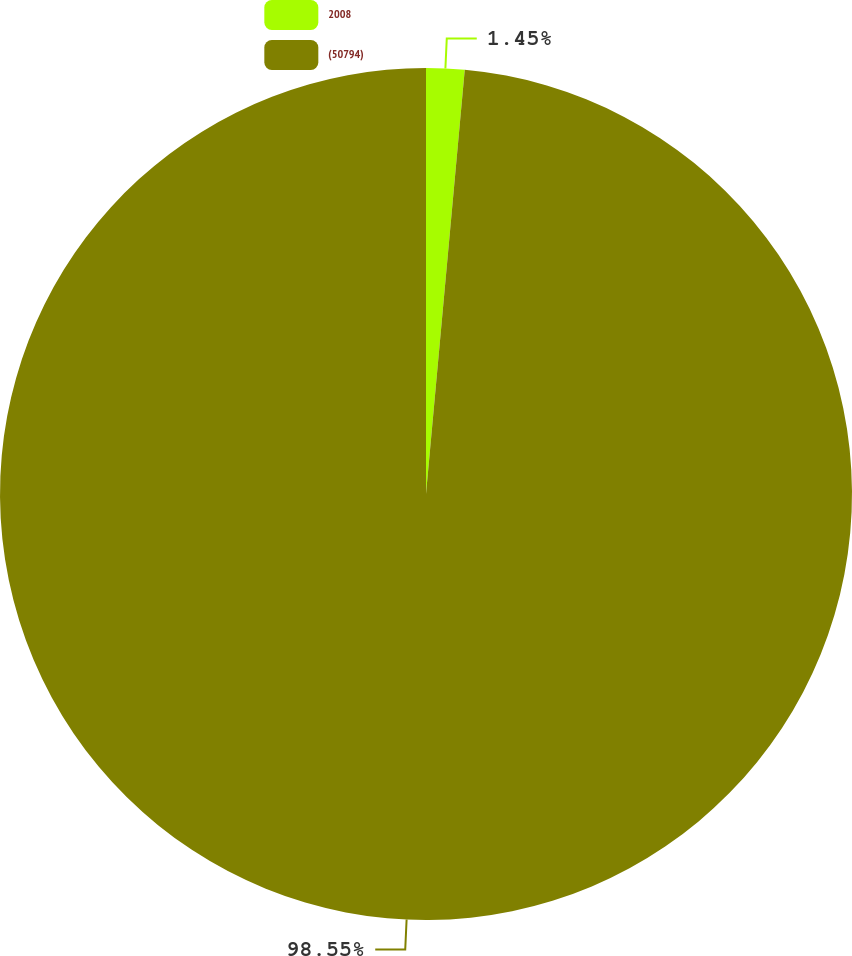Convert chart to OTSL. <chart><loc_0><loc_0><loc_500><loc_500><pie_chart><fcel>2008<fcel>(50794)<nl><fcel>1.45%<fcel>98.55%<nl></chart> 